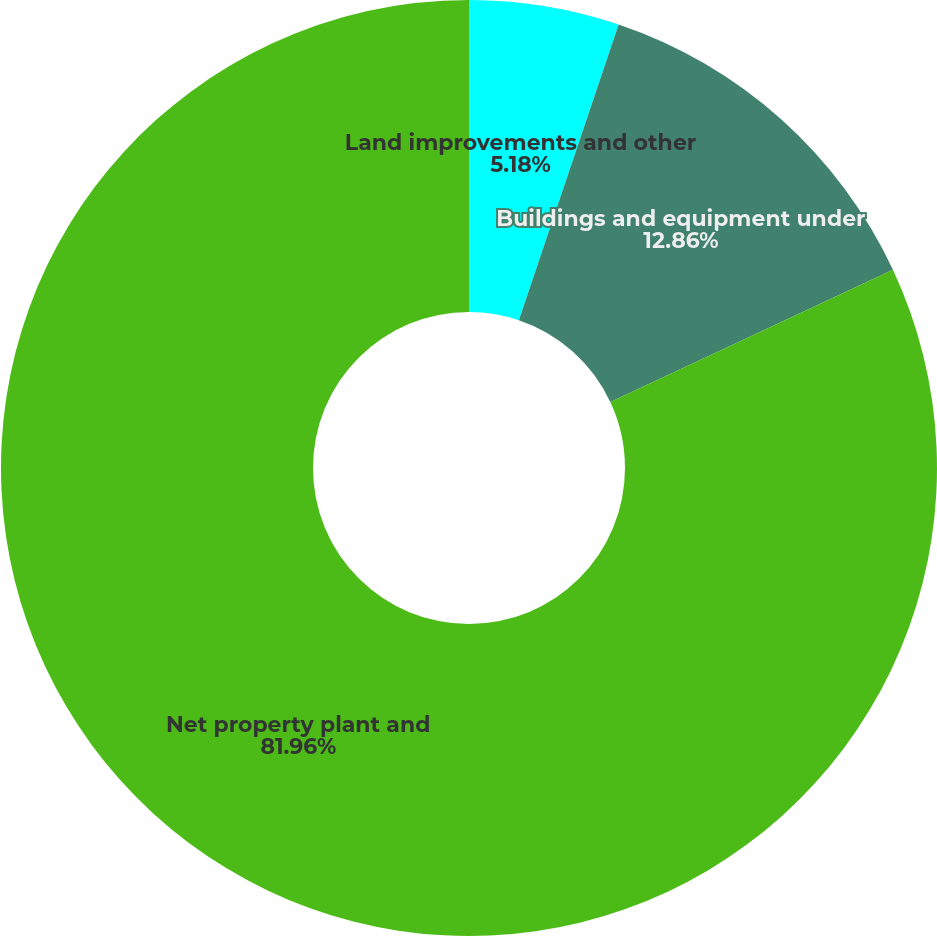Convert chart to OTSL. <chart><loc_0><loc_0><loc_500><loc_500><pie_chart><fcel>Land improvements and other<fcel>Buildings and equipment under<fcel>Net property plant and<nl><fcel>5.18%<fcel>12.86%<fcel>81.97%<nl></chart> 